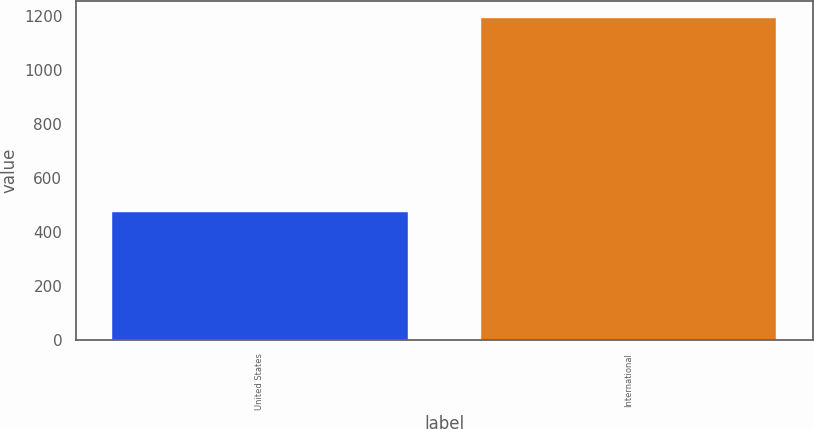Convert chart. <chart><loc_0><loc_0><loc_500><loc_500><bar_chart><fcel>United States<fcel>International<nl><fcel>474.5<fcel>1194.2<nl></chart> 